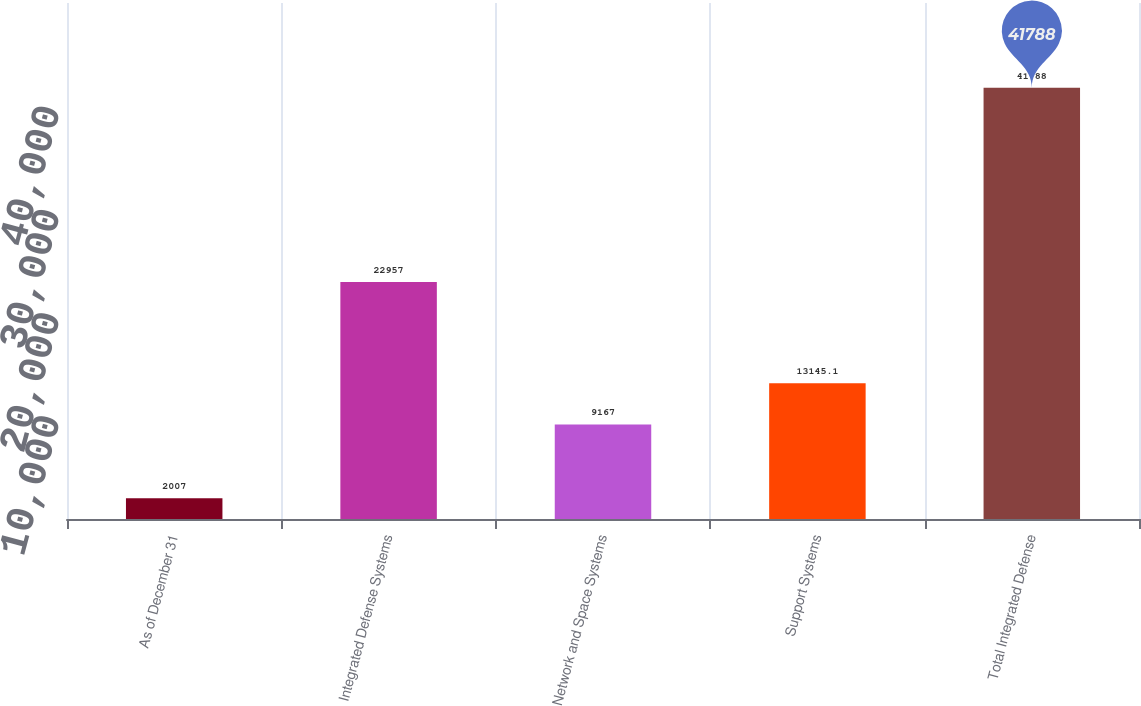Convert chart. <chart><loc_0><loc_0><loc_500><loc_500><bar_chart><fcel>As of December 31<fcel>Integrated Defense Systems<fcel>Network and Space Systems<fcel>Support Systems<fcel>Total Integrated Defense<nl><fcel>2007<fcel>22957<fcel>9167<fcel>13145.1<fcel>41788<nl></chart> 